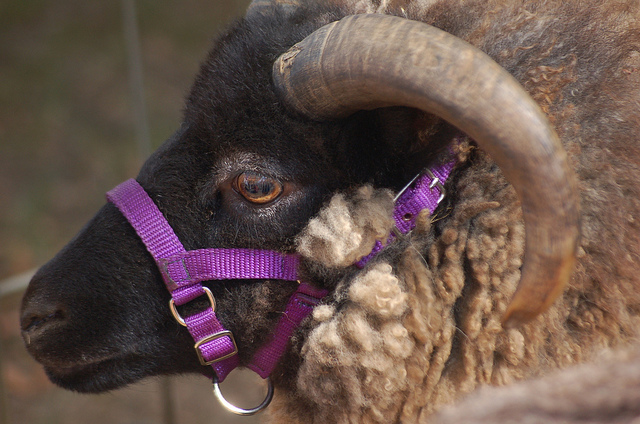<image>Is this animal a pet? It is ambiguous if the animal is a pet. Is this animal a pet? I don't know if this animal is a pet. It can be both a pet or not a pet. 